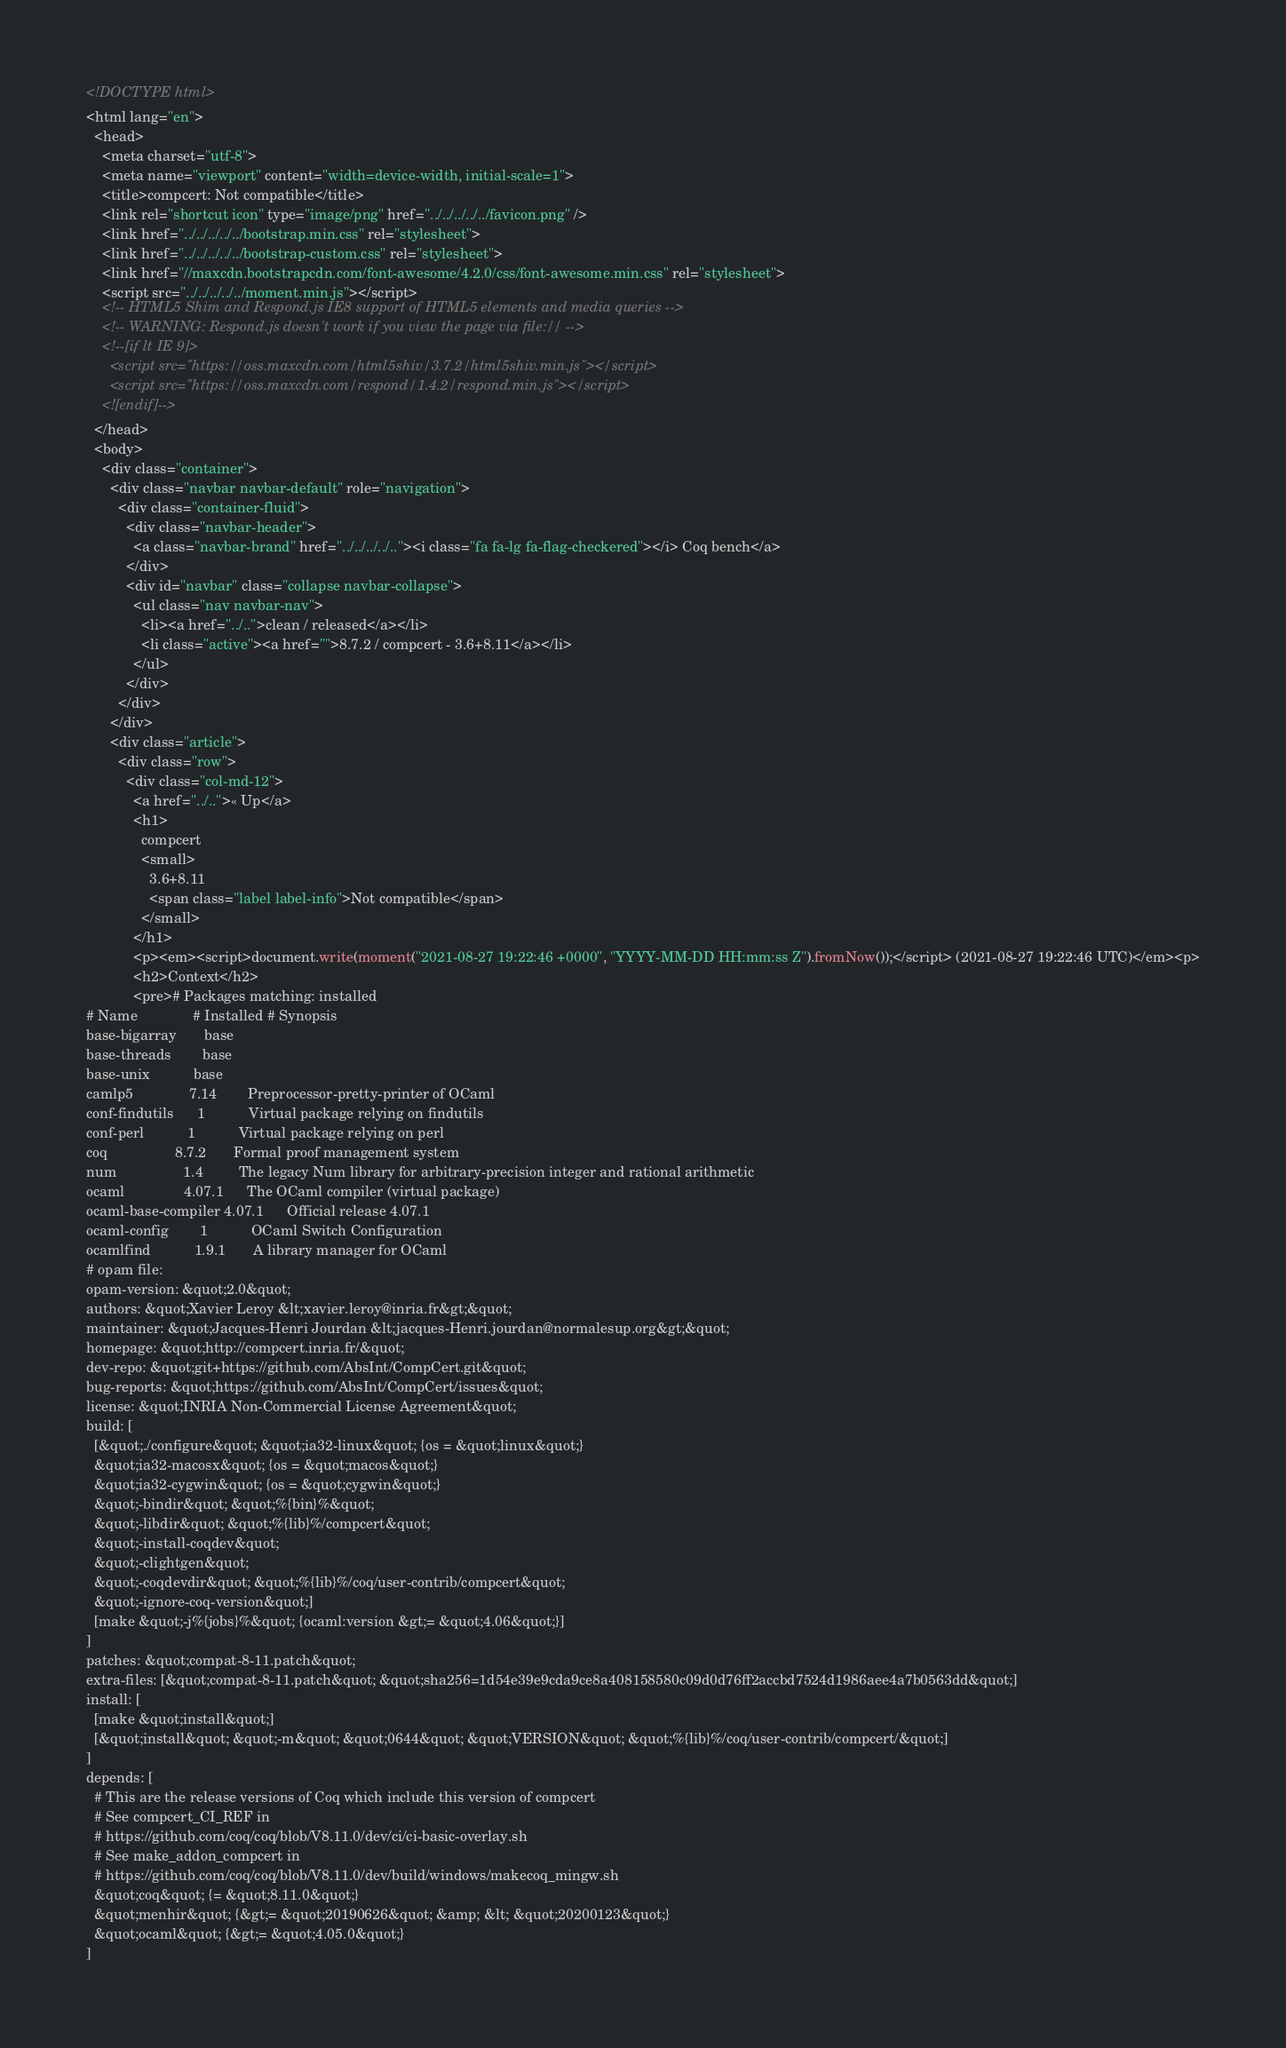<code> <loc_0><loc_0><loc_500><loc_500><_HTML_><!DOCTYPE html>
<html lang="en">
  <head>
    <meta charset="utf-8">
    <meta name="viewport" content="width=device-width, initial-scale=1">
    <title>compcert: Not compatible</title>
    <link rel="shortcut icon" type="image/png" href="../../../../../favicon.png" />
    <link href="../../../../../bootstrap.min.css" rel="stylesheet">
    <link href="../../../../../bootstrap-custom.css" rel="stylesheet">
    <link href="//maxcdn.bootstrapcdn.com/font-awesome/4.2.0/css/font-awesome.min.css" rel="stylesheet">
    <script src="../../../../../moment.min.js"></script>
    <!-- HTML5 Shim and Respond.js IE8 support of HTML5 elements and media queries -->
    <!-- WARNING: Respond.js doesn't work if you view the page via file:// -->
    <!--[if lt IE 9]>
      <script src="https://oss.maxcdn.com/html5shiv/3.7.2/html5shiv.min.js"></script>
      <script src="https://oss.maxcdn.com/respond/1.4.2/respond.min.js"></script>
    <![endif]-->
  </head>
  <body>
    <div class="container">
      <div class="navbar navbar-default" role="navigation">
        <div class="container-fluid">
          <div class="navbar-header">
            <a class="navbar-brand" href="../../../../.."><i class="fa fa-lg fa-flag-checkered"></i> Coq bench</a>
          </div>
          <div id="navbar" class="collapse navbar-collapse">
            <ul class="nav navbar-nav">
              <li><a href="../..">clean / released</a></li>
              <li class="active"><a href="">8.7.2 / compcert - 3.6+8.11</a></li>
            </ul>
          </div>
        </div>
      </div>
      <div class="article">
        <div class="row">
          <div class="col-md-12">
            <a href="../..">« Up</a>
            <h1>
              compcert
              <small>
                3.6+8.11
                <span class="label label-info">Not compatible</span>
              </small>
            </h1>
            <p><em><script>document.write(moment("2021-08-27 19:22:46 +0000", "YYYY-MM-DD HH:mm:ss Z").fromNow());</script> (2021-08-27 19:22:46 UTC)</em><p>
            <h2>Context</h2>
            <pre># Packages matching: installed
# Name              # Installed # Synopsis
base-bigarray       base
base-threads        base
base-unix           base
camlp5              7.14        Preprocessor-pretty-printer of OCaml
conf-findutils      1           Virtual package relying on findutils
conf-perl           1           Virtual package relying on perl
coq                 8.7.2       Formal proof management system
num                 1.4         The legacy Num library for arbitrary-precision integer and rational arithmetic
ocaml               4.07.1      The OCaml compiler (virtual package)
ocaml-base-compiler 4.07.1      Official release 4.07.1
ocaml-config        1           OCaml Switch Configuration
ocamlfind           1.9.1       A library manager for OCaml
# opam file:
opam-version: &quot;2.0&quot;
authors: &quot;Xavier Leroy &lt;xavier.leroy@inria.fr&gt;&quot;
maintainer: &quot;Jacques-Henri Jourdan &lt;jacques-Henri.jourdan@normalesup.org&gt;&quot;
homepage: &quot;http://compcert.inria.fr/&quot;
dev-repo: &quot;git+https://github.com/AbsInt/CompCert.git&quot;
bug-reports: &quot;https://github.com/AbsInt/CompCert/issues&quot;
license: &quot;INRIA Non-Commercial License Agreement&quot;
build: [
  [&quot;./configure&quot; &quot;ia32-linux&quot; {os = &quot;linux&quot;}
  &quot;ia32-macosx&quot; {os = &quot;macos&quot;}
  &quot;ia32-cygwin&quot; {os = &quot;cygwin&quot;}
  &quot;-bindir&quot; &quot;%{bin}%&quot;
  &quot;-libdir&quot; &quot;%{lib}%/compcert&quot;
  &quot;-install-coqdev&quot;
  &quot;-clightgen&quot;
  &quot;-coqdevdir&quot; &quot;%{lib}%/coq/user-contrib/compcert&quot;
  &quot;-ignore-coq-version&quot;]
  [make &quot;-j%{jobs}%&quot; {ocaml:version &gt;= &quot;4.06&quot;}]
]
patches: &quot;compat-8-11.patch&quot;
extra-files: [&quot;compat-8-11.patch&quot; &quot;sha256=1d54e39e9cda9ce8a408158580c09d0d76ff2accbd7524d1986aee4a7b0563dd&quot;]
install: [
  [make &quot;install&quot;]
  [&quot;install&quot; &quot;-m&quot; &quot;0644&quot; &quot;VERSION&quot; &quot;%{lib}%/coq/user-contrib/compcert/&quot;]
]
depends: [
  # This are the release versions of Coq which include this version of compcert
  # See compcert_CI_REF in
  # https://github.com/coq/coq/blob/V8.11.0/dev/ci/ci-basic-overlay.sh
  # See make_addon_compcert in
  # https://github.com/coq/coq/blob/V8.11.0/dev/build/windows/makecoq_mingw.sh
  &quot;coq&quot; {= &quot;8.11.0&quot;}
  &quot;menhir&quot; {&gt;= &quot;20190626&quot; &amp; &lt; &quot;20200123&quot;}
  &quot;ocaml&quot; {&gt;= &quot;4.05.0&quot;}
]</code> 